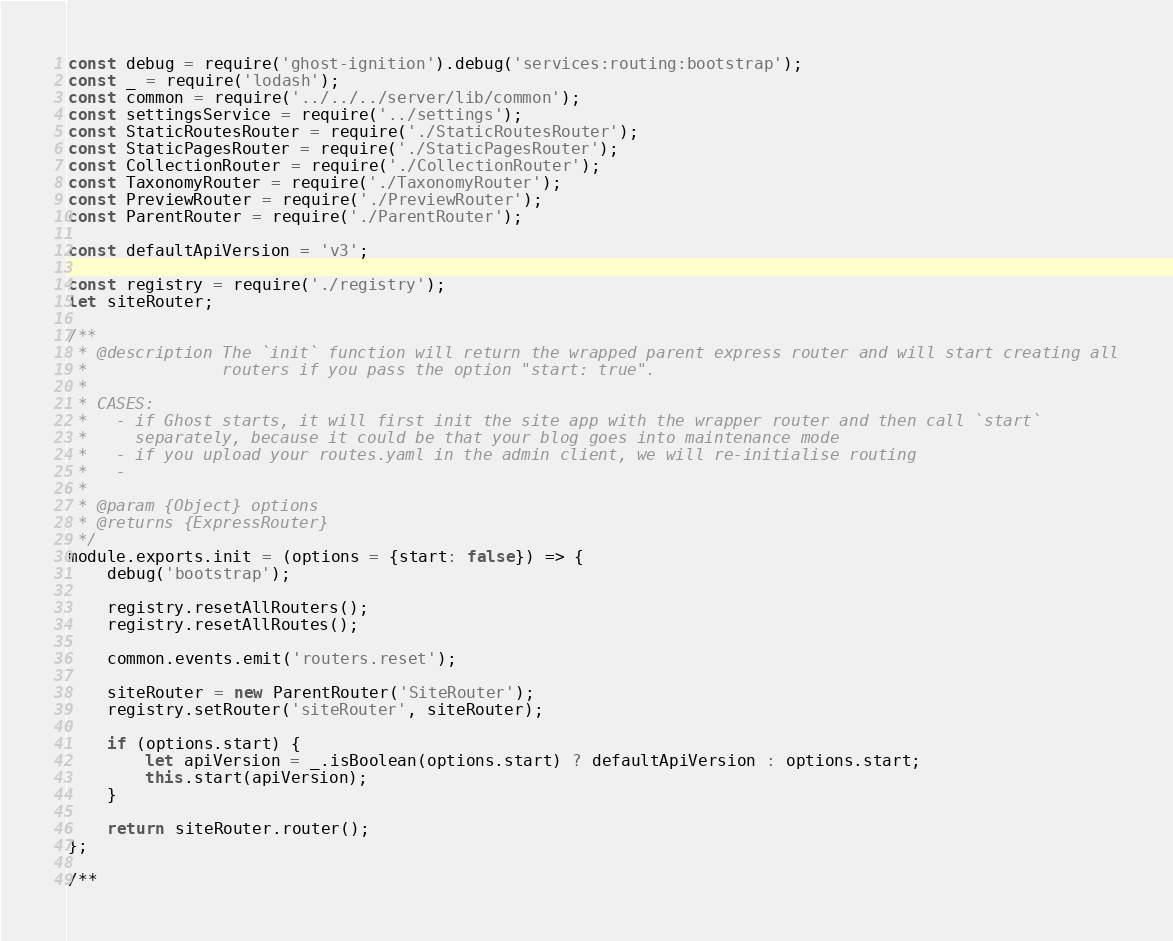<code> <loc_0><loc_0><loc_500><loc_500><_JavaScript_>const debug = require('ghost-ignition').debug('services:routing:bootstrap');
const _ = require('lodash');
const common = require('../../../server/lib/common');
const settingsService = require('../settings');
const StaticRoutesRouter = require('./StaticRoutesRouter');
const StaticPagesRouter = require('./StaticPagesRouter');
const CollectionRouter = require('./CollectionRouter');
const TaxonomyRouter = require('./TaxonomyRouter');
const PreviewRouter = require('./PreviewRouter');
const ParentRouter = require('./ParentRouter');

const defaultApiVersion = 'v3';

const registry = require('./registry');
let siteRouter;

/**
 * @description The `init` function will return the wrapped parent express router and will start creating all
 *              routers if you pass the option "start: true".
 *
 * CASES:
 *   - if Ghost starts, it will first init the site app with the wrapper router and then call `start`
 *     separately, because it could be that your blog goes into maintenance mode
 *   - if you upload your routes.yaml in the admin client, we will re-initialise routing
 *   -
 *
 * @param {Object} options
 * @returns {ExpressRouter}
 */
module.exports.init = (options = {start: false}) => {
    debug('bootstrap');

    registry.resetAllRouters();
    registry.resetAllRoutes();

    common.events.emit('routers.reset');

    siteRouter = new ParentRouter('SiteRouter');
    registry.setRouter('siteRouter', siteRouter);

    if (options.start) {
        let apiVersion = _.isBoolean(options.start) ? defaultApiVersion : options.start;
        this.start(apiVersion);
    }

    return siteRouter.router();
};

/**</code> 